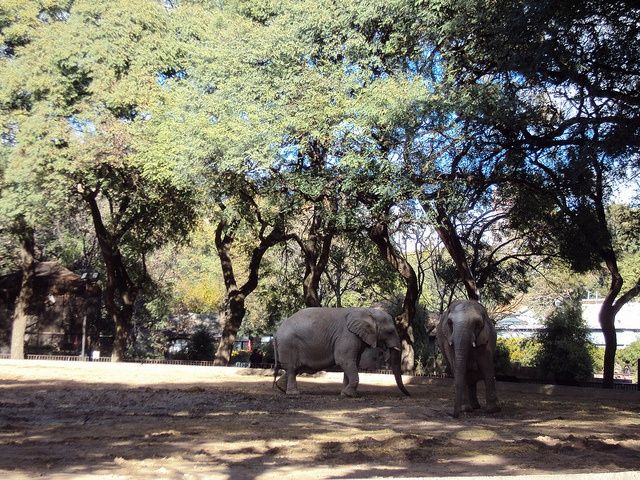Describe the objects in this image and their specific colors. I can see elephant in tan, gray, and black tones, elephant in tan, black, gray, and darkgray tones, car in tan, black, maroon, and gray tones, car in tan, black, gray, darkgray, and lightgray tones, and people in tan, darkgray, gray, and black tones in this image. 